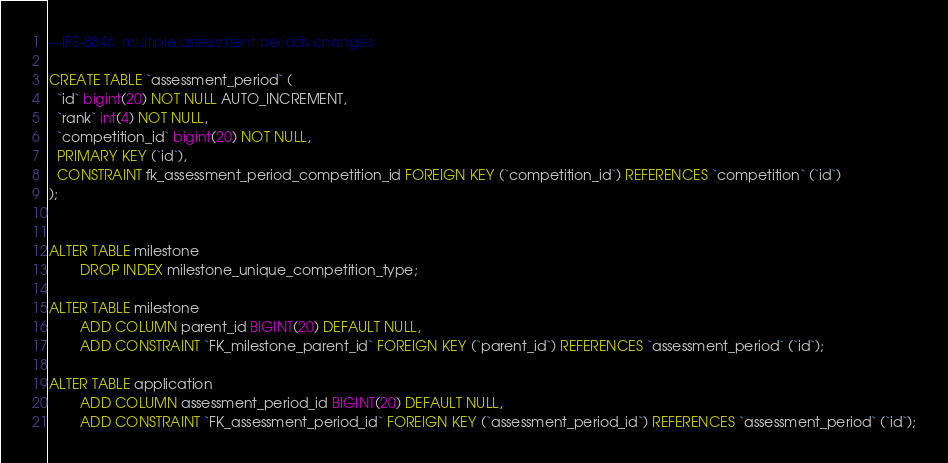<code> <loc_0><loc_0><loc_500><loc_500><_SQL_>-- IFS-8846, multiple assessment periods changes

CREATE TABLE `assessment_period` (
  `id` bigint(20) NOT NULL AUTO_INCREMENT,
  `rank` int(4) NOT NULL,
  `competition_id` bigint(20) NOT NULL,
  PRIMARY KEY (`id`),
  CONSTRAINT fk_assessment_period_competition_id FOREIGN KEY (`competition_id`) REFERENCES `competition` (`id`)
);


ALTER TABLE milestone
        DROP INDEX milestone_unique_competition_type;

ALTER TABLE milestone
        ADD COLUMN parent_id BIGINT(20) DEFAULT NULL,
        ADD CONSTRAINT `FK_milestone_parent_id` FOREIGN KEY (`parent_id`) REFERENCES `assessment_period` (`id`);

ALTER TABLE application
        ADD COLUMN assessment_period_id BIGINT(20) DEFAULT NULL,
        ADD CONSTRAINT `FK_assessment_period_id` FOREIGN KEY (`assessment_period_id`) REFERENCES `assessment_period` (`id`);
</code> 